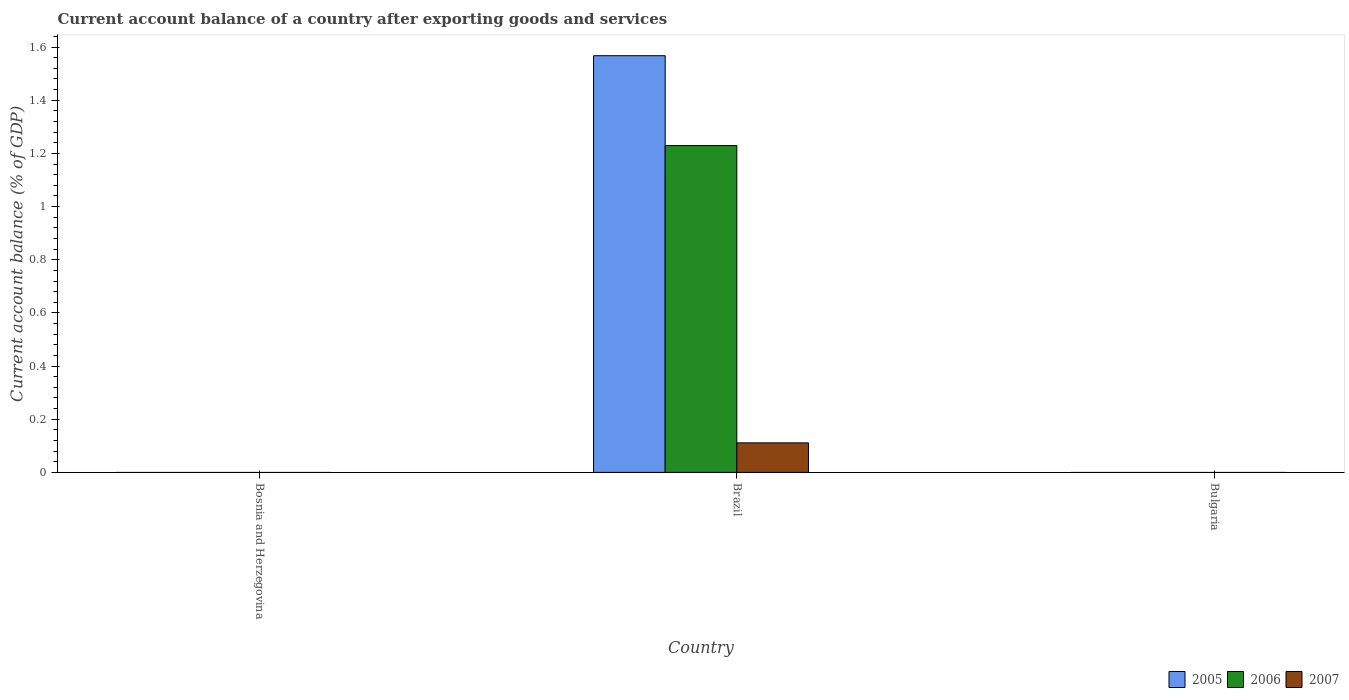How many different coloured bars are there?
Make the answer very short. 3. Are the number of bars per tick equal to the number of legend labels?
Your answer should be compact. No. How many bars are there on the 2nd tick from the left?
Offer a terse response. 3. What is the account balance in 2005 in Brazil?
Your answer should be compact. 1.57. Across all countries, what is the maximum account balance in 2005?
Keep it short and to the point. 1.57. What is the total account balance in 2005 in the graph?
Your answer should be compact. 1.57. What is the difference between the account balance in 2005 in Bosnia and Herzegovina and the account balance in 2007 in Brazil?
Give a very brief answer. -0.11. What is the average account balance in 2006 per country?
Provide a succinct answer. 0.41. What is the difference between the account balance of/in 2005 and account balance of/in 2007 in Brazil?
Offer a very short reply. 1.46. In how many countries, is the account balance in 2007 greater than 1.3200000000000003 %?
Make the answer very short. 0. What is the difference between the highest and the lowest account balance in 2007?
Your response must be concise. 0.11. How many bars are there?
Your answer should be very brief. 3. How many countries are there in the graph?
Give a very brief answer. 3. What is the difference between two consecutive major ticks on the Y-axis?
Offer a very short reply. 0.2. Are the values on the major ticks of Y-axis written in scientific E-notation?
Your answer should be compact. No. Where does the legend appear in the graph?
Provide a short and direct response. Bottom right. What is the title of the graph?
Ensure brevity in your answer.  Current account balance of a country after exporting goods and services. What is the label or title of the X-axis?
Offer a very short reply. Country. What is the label or title of the Y-axis?
Provide a short and direct response. Current account balance (% of GDP). What is the Current account balance (% of GDP) of 2005 in Bosnia and Herzegovina?
Your answer should be very brief. 0. What is the Current account balance (% of GDP) of 2006 in Bosnia and Herzegovina?
Provide a succinct answer. 0. What is the Current account balance (% of GDP) in 2005 in Brazil?
Your answer should be very brief. 1.57. What is the Current account balance (% of GDP) in 2006 in Brazil?
Make the answer very short. 1.23. What is the Current account balance (% of GDP) of 2007 in Brazil?
Make the answer very short. 0.11. What is the Current account balance (% of GDP) of 2006 in Bulgaria?
Provide a short and direct response. 0. Across all countries, what is the maximum Current account balance (% of GDP) of 2005?
Ensure brevity in your answer.  1.57. Across all countries, what is the maximum Current account balance (% of GDP) of 2006?
Offer a terse response. 1.23. Across all countries, what is the maximum Current account balance (% of GDP) of 2007?
Make the answer very short. 0.11. Across all countries, what is the minimum Current account balance (% of GDP) of 2006?
Ensure brevity in your answer.  0. What is the total Current account balance (% of GDP) in 2005 in the graph?
Give a very brief answer. 1.57. What is the total Current account balance (% of GDP) in 2006 in the graph?
Provide a succinct answer. 1.23. What is the total Current account balance (% of GDP) in 2007 in the graph?
Make the answer very short. 0.11. What is the average Current account balance (% of GDP) in 2005 per country?
Your answer should be compact. 0.52. What is the average Current account balance (% of GDP) in 2006 per country?
Offer a very short reply. 0.41. What is the average Current account balance (% of GDP) in 2007 per country?
Offer a very short reply. 0.04. What is the difference between the Current account balance (% of GDP) of 2005 and Current account balance (% of GDP) of 2006 in Brazil?
Ensure brevity in your answer.  0.34. What is the difference between the Current account balance (% of GDP) of 2005 and Current account balance (% of GDP) of 2007 in Brazil?
Your response must be concise. 1.46. What is the difference between the Current account balance (% of GDP) in 2006 and Current account balance (% of GDP) in 2007 in Brazil?
Your answer should be compact. 1.12. What is the difference between the highest and the lowest Current account balance (% of GDP) in 2005?
Offer a very short reply. 1.57. What is the difference between the highest and the lowest Current account balance (% of GDP) of 2006?
Your answer should be compact. 1.23. What is the difference between the highest and the lowest Current account balance (% of GDP) of 2007?
Provide a succinct answer. 0.11. 